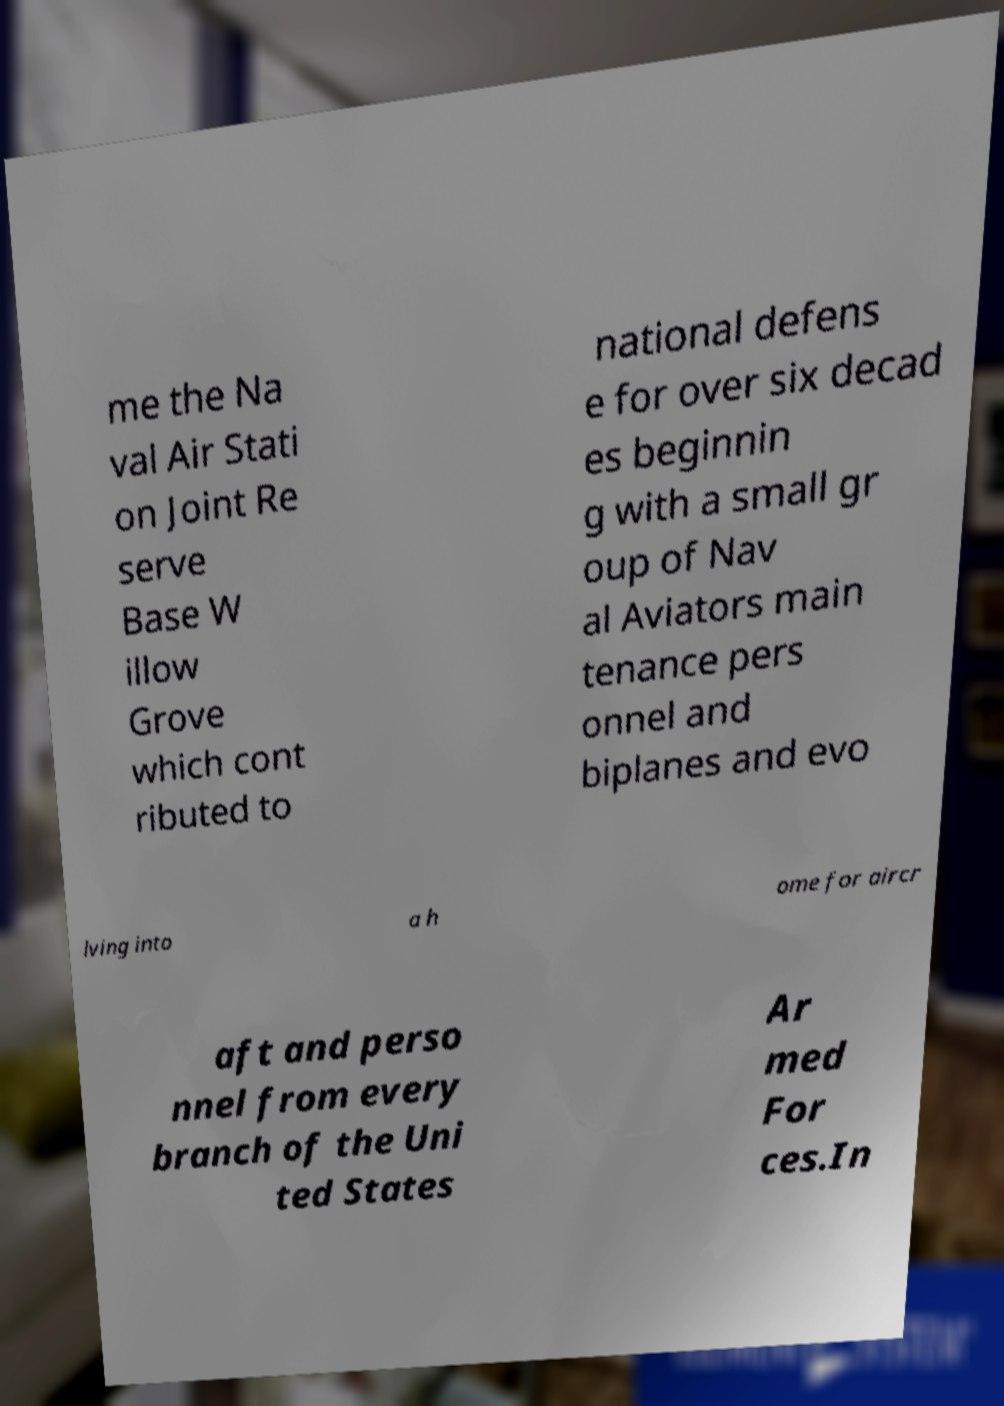Could you assist in decoding the text presented in this image and type it out clearly? me the Na val Air Stati on Joint Re serve Base W illow Grove which cont ributed to national defens e for over six decad es beginnin g with a small gr oup of Nav al Aviators main tenance pers onnel and biplanes and evo lving into a h ome for aircr aft and perso nnel from every branch of the Uni ted States Ar med For ces.In 